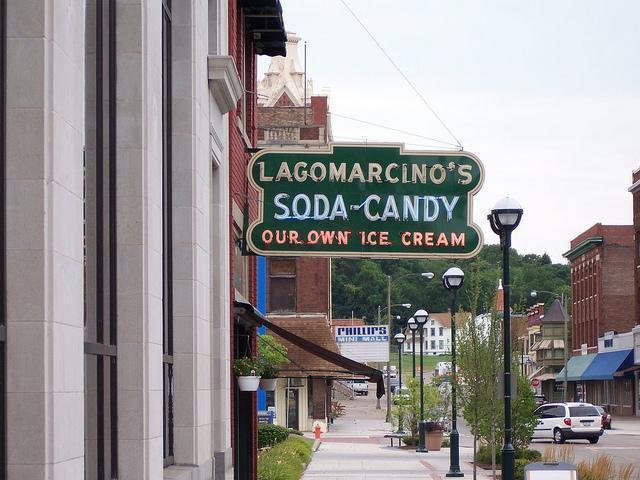How many flags do you see?
Give a very brief answer. 0. 